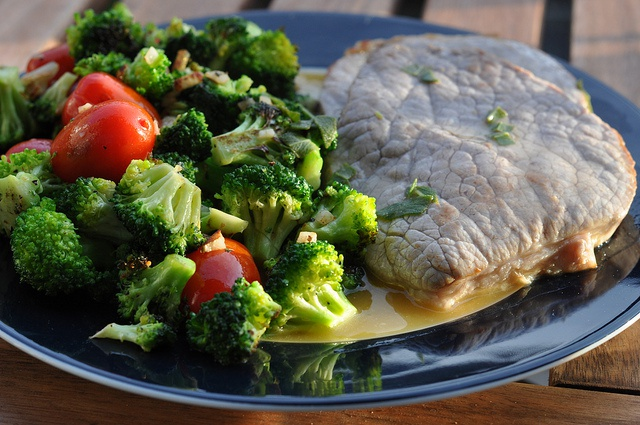Describe the objects in this image and their specific colors. I can see broccoli in gray, black, darkgreen, and olive tones, broccoli in gray, black, olive, and darkgreen tones, broccoli in gray, black, darkgreen, and olive tones, broccoli in gray, black, olive, and darkgreen tones, and broccoli in gray, darkgreen, and green tones in this image. 